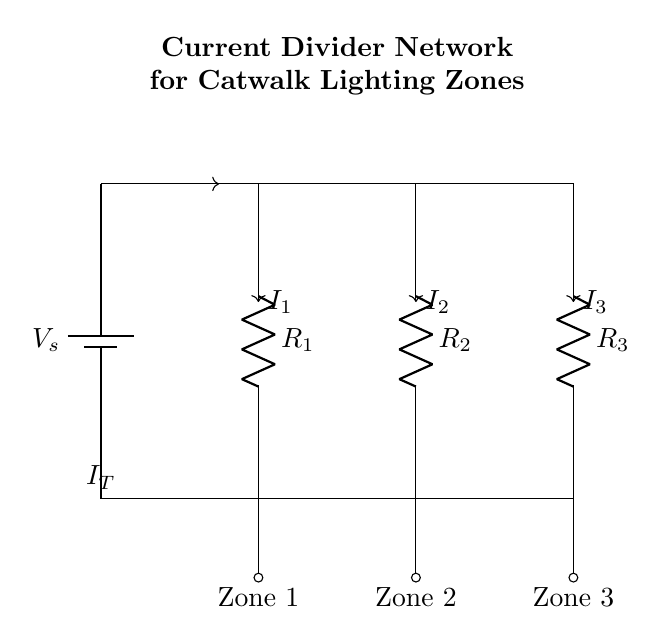What is the main power source in the circuit? The main power source is the battery, labeled as Vs.
Answer: Battery What are the resistances in the current divider network? The resistances R1, R2, and R3 are part of the current divider network.
Answer: R1, R2, R3 How many lighting zones are powered by this circuit? There are three lighting zones indicated by the labels below the outputs.
Answer: Three What current flows through R2? The current through R2 is labeled as I2, which is the current that flows to Zone 2.
Answer: I2 Which zone receives the current from R1? Zone 1 receives the current from R1, as it is connected directly to the output of R1.
Answer: Zone 1 What happens to the total current in the circuit? The total current It is divided among the three resistances, which alter the individual currents I1, I2, and I3, based on their resistance values.
Answer: Divided What is the function of the current divider network in this circuit? The current divider network allows for the adjustment of power distribution to multiple lighting zones effectively.
Answer: Adjust power distribution 